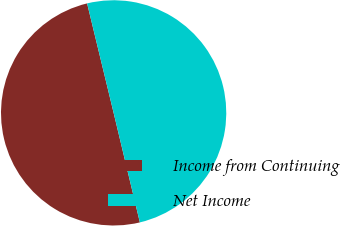Convert chart. <chart><loc_0><loc_0><loc_500><loc_500><pie_chart><fcel>Income from Continuing<fcel>Net Income<nl><fcel>49.96%<fcel>50.04%<nl></chart> 